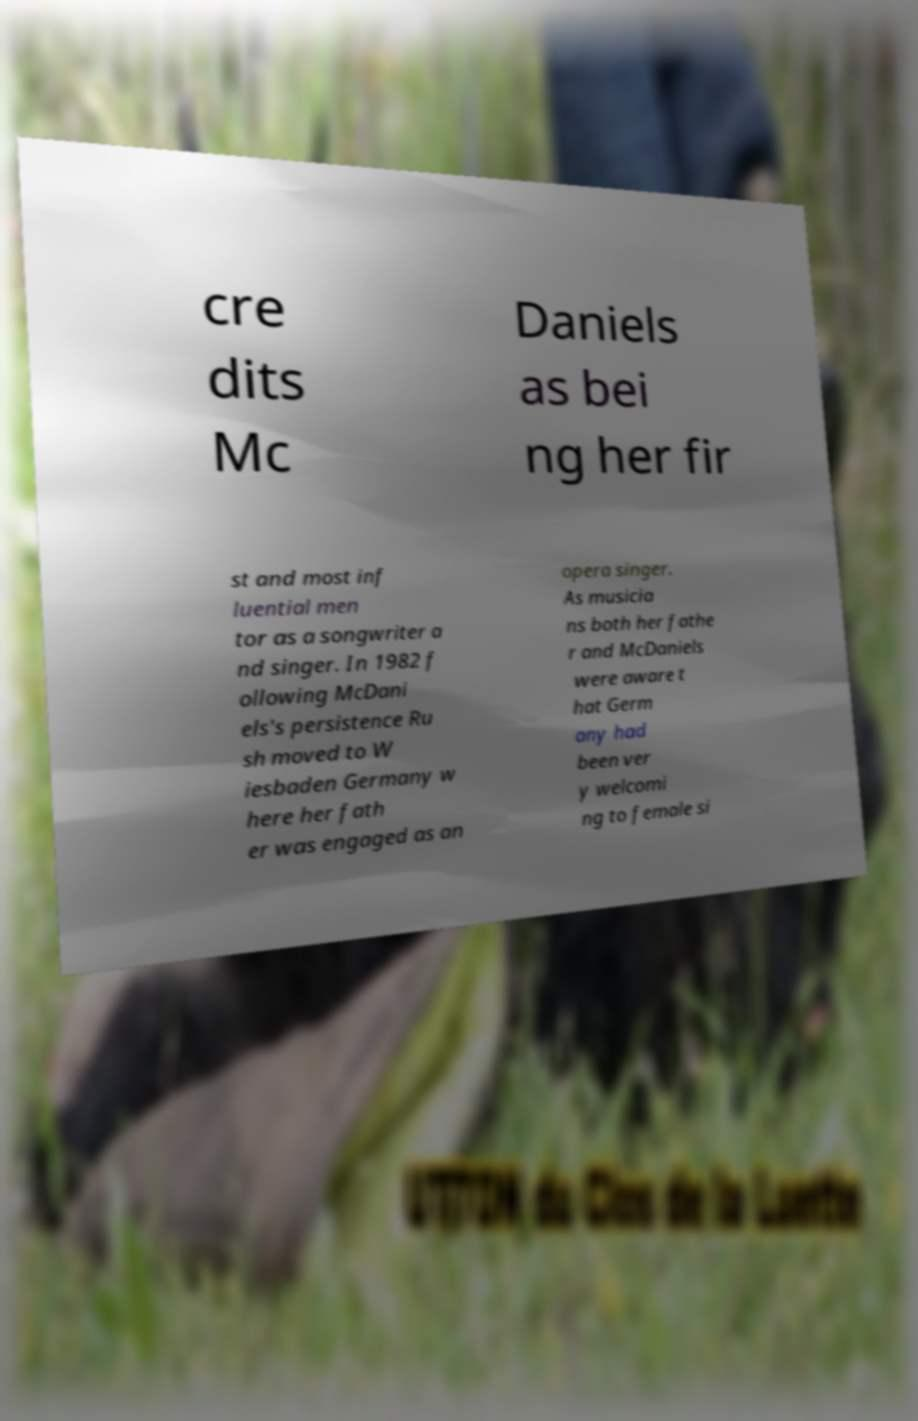Can you accurately transcribe the text from the provided image for me? cre dits Mc Daniels as bei ng her fir st and most inf luential men tor as a songwriter a nd singer. In 1982 f ollowing McDani els's persistence Ru sh moved to W iesbaden Germany w here her fath er was engaged as an opera singer. As musicia ns both her fathe r and McDaniels were aware t hat Germ any had been ver y welcomi ng to female si 